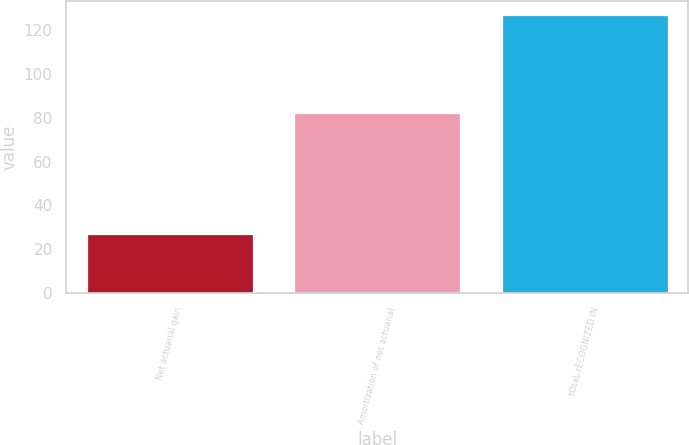<chart> <loc_0><loc_0><loc_500><loc_500><bar_chart><fcel>Net actuarial gain<fcel>Amortization of net actuarial<fcel>tOtaL rECOGNIZED IN<nl><fcel>27<fcel>82<fcel>127<nl></chart> 